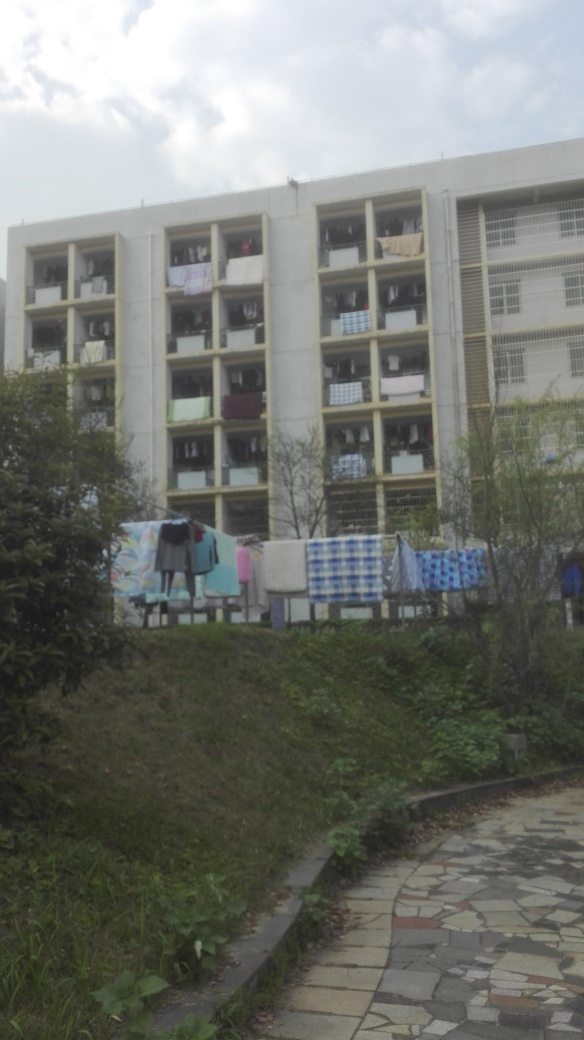Can you tell me something about the location this picture might have been taken in? The building's style and the fact that laundry is being hung outside to dry suggest this might be an image from a suburban or semi-urban area in a region where residents often air-dry their clothes, possibly indicating a warm climate or cultural preference for air-drying over machine-drying. 